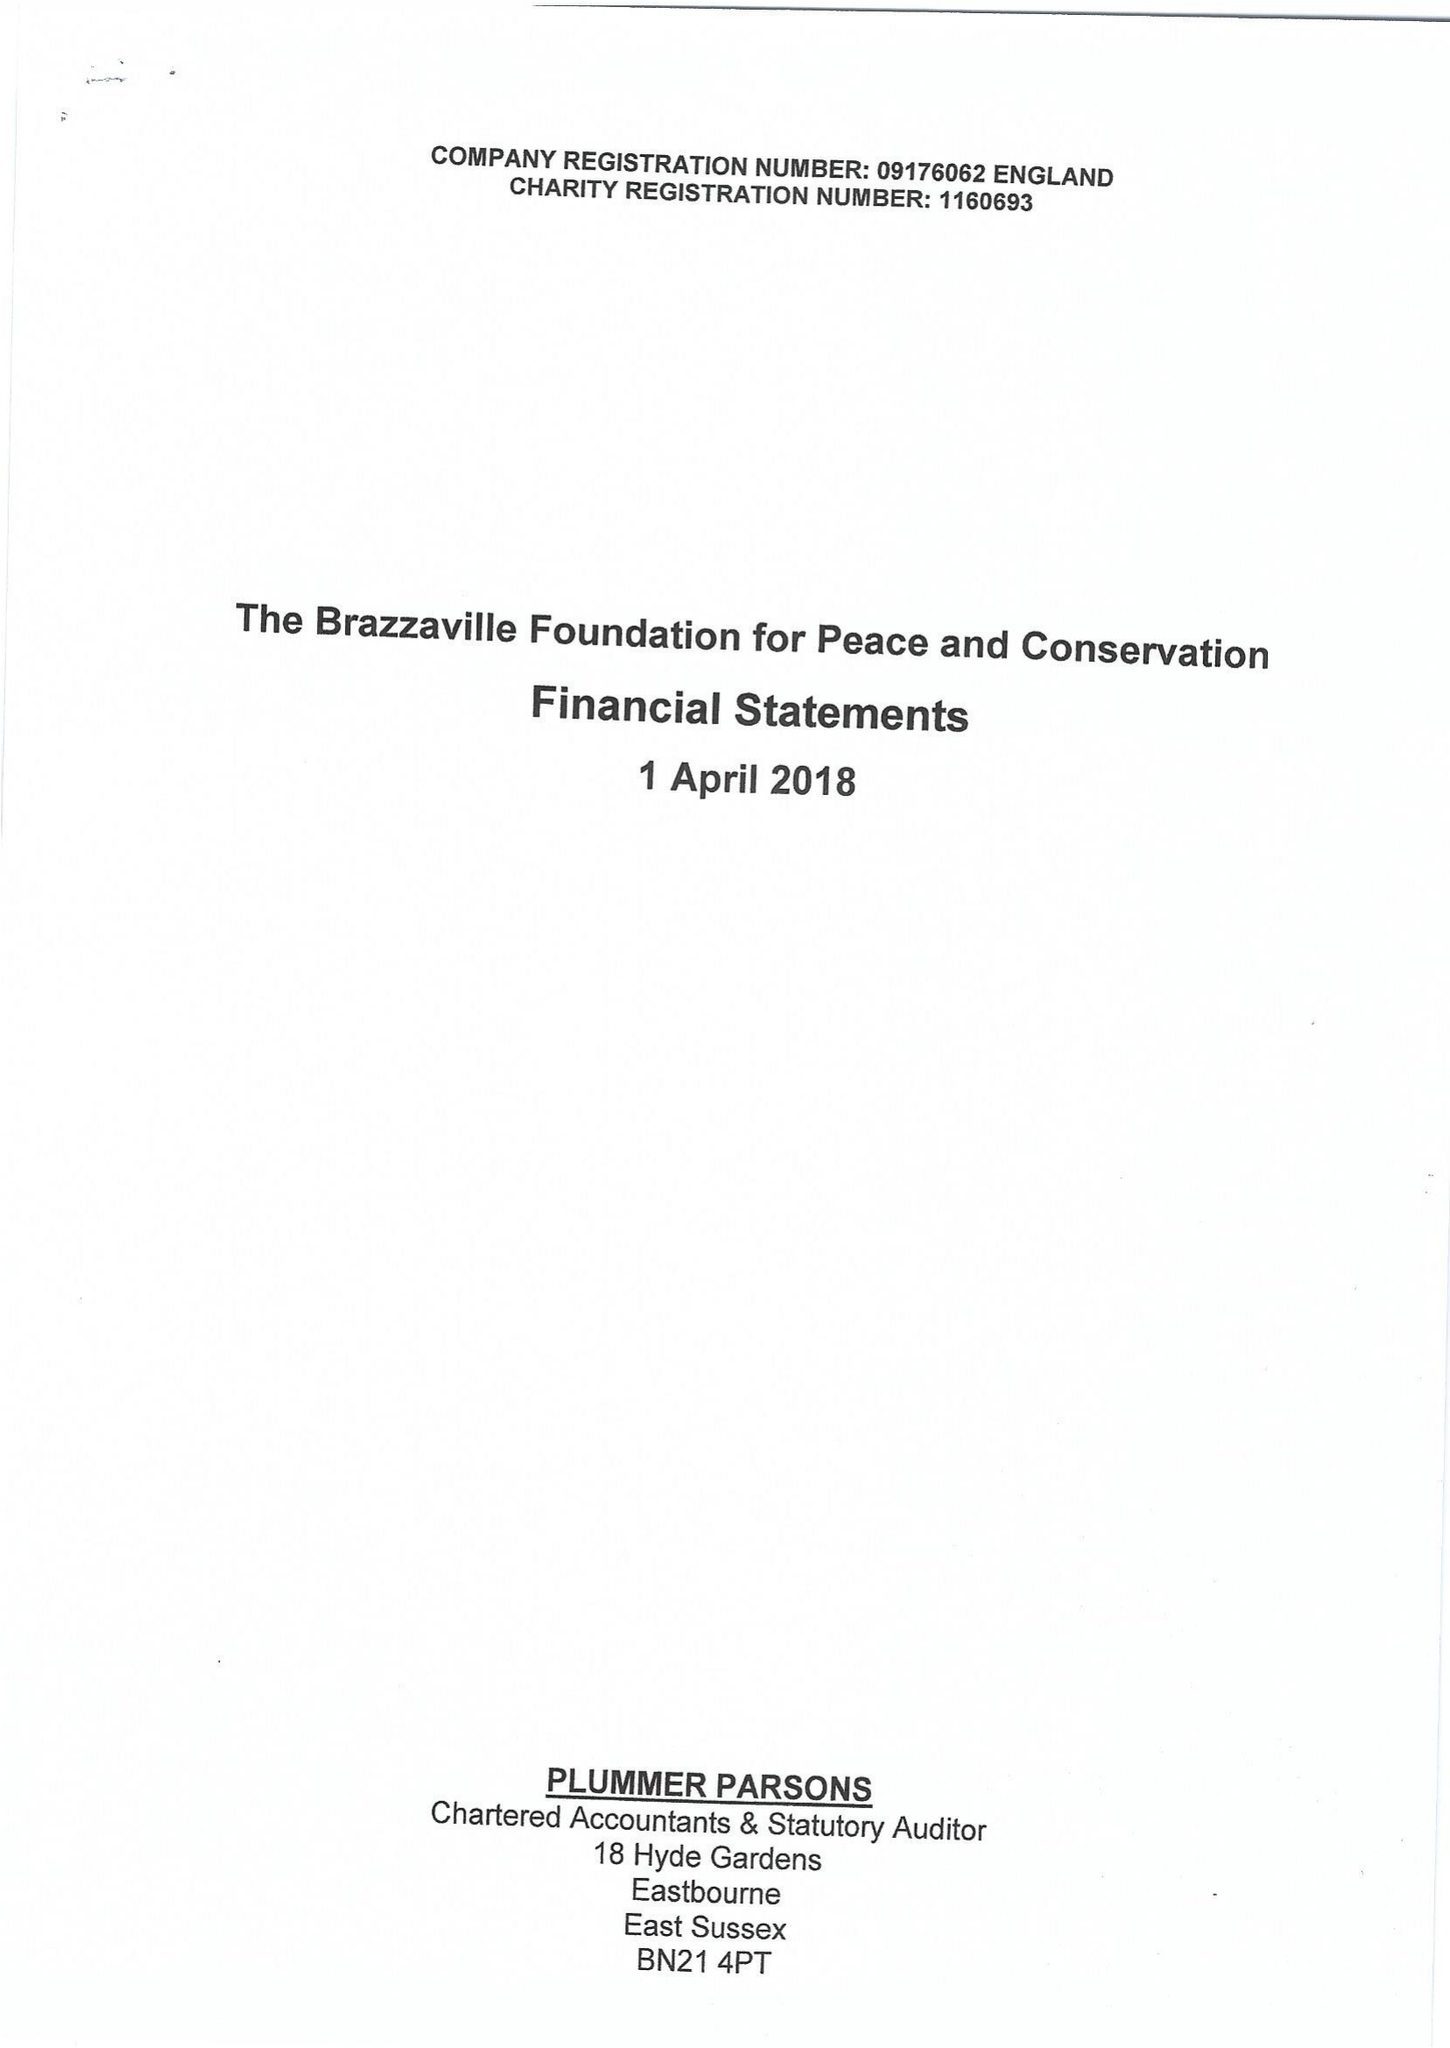What is the value for the address__post_town?
Answer the question using a single word or phrase. LONDON 